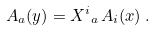Convert formula to latex. <formula><loc_0><loc_0><loc_500><loc_500>A _ { a } ( { y } ) = { X ^ { i } } _ { a } \, A _ { i } ( { x } ) \, .</formula> 